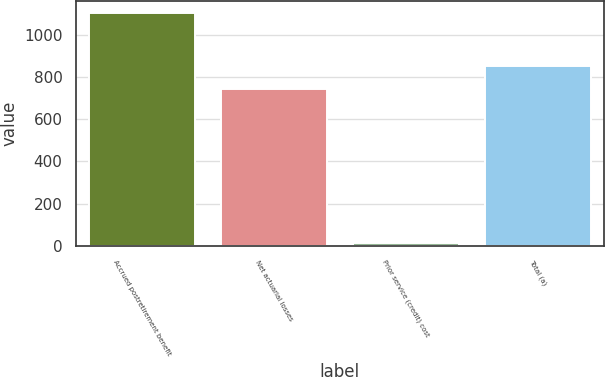<chart> <loc_0><loc_0><loc_500><loc_500><bar_chart><fcel>Accrued postretirement benefit<fcel>Net actuarial losses<fcel>Prior service (credit) cost<fcel>Total (a)<nl><fcel>1102<fcel>741<fcel>14<fcel>849.8<nl></chart> 